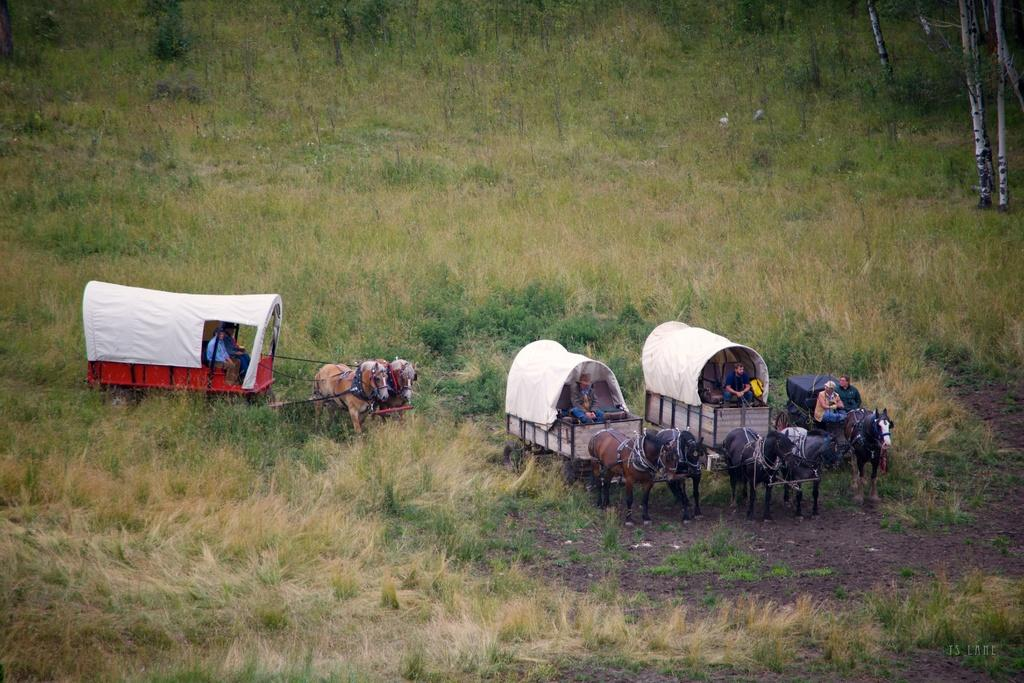How many horse carts are present in the image? There are 4 horse carts in the image. Are there any passengers in the horse carts? Yes, there are people in the horse carts. What type of terrain can be seen in the image? There is grass visible in the image. What type of throat lozenges are being handed out to the people in the horse carts? There is no mention of throat lozenges or any similar items in the image. 